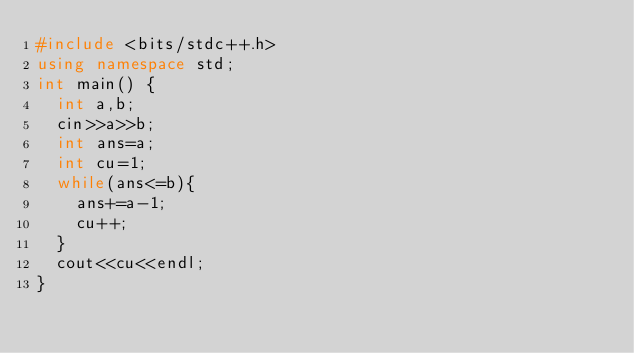Convert code to text. <code><loc_0><loc_0><loc_500><loc_500><_C++_>#include <bits/stdc++.h>
using namespace std;
int main() {
  int a,b;
  cin>>a>>b;
  int ans=a;
  int cu=1;
  while(ans<=b){
    ans+=a-1;
    cu++;
  }
  cout<<cu<<endl;
}
</code> 